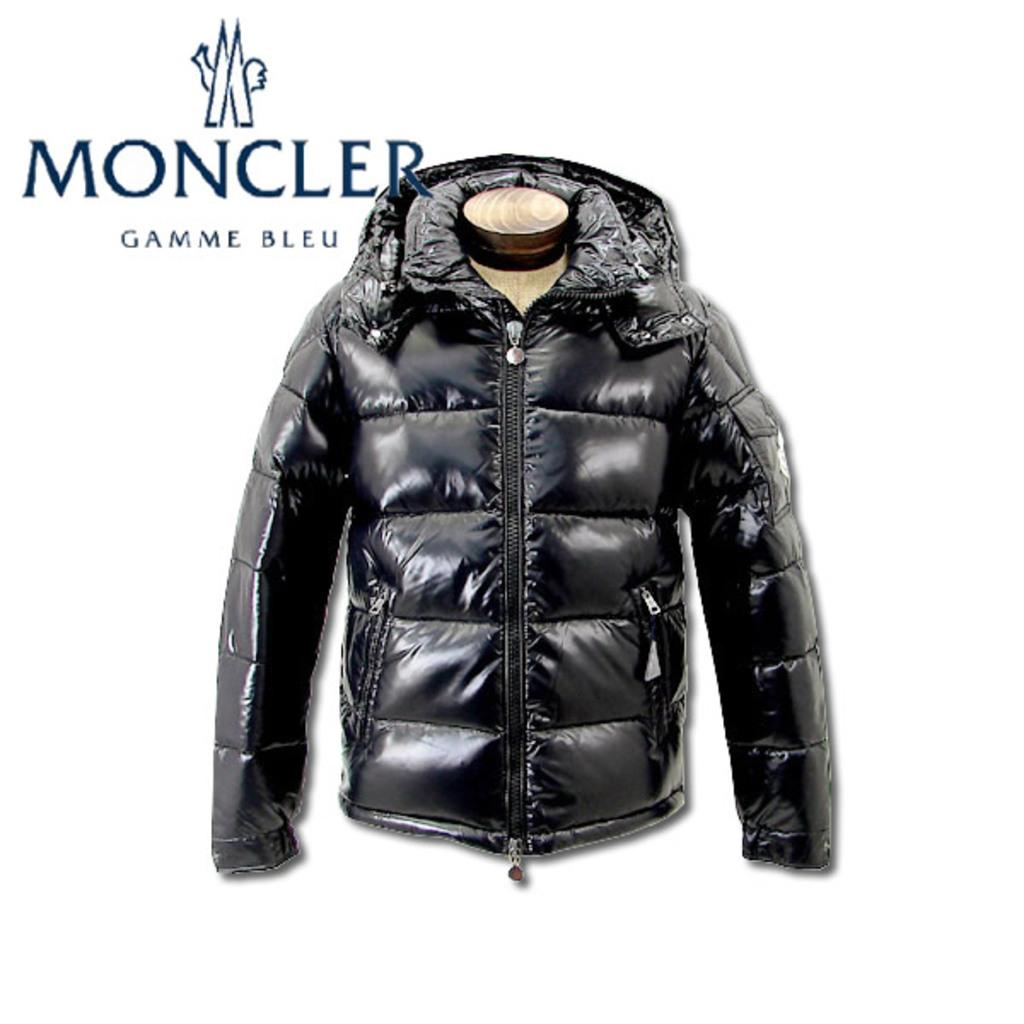What type of clothing is visible in the image? There is a jacket in the image. What color is the jacket? The jacket is black in color. What is the color of the background in the image? The background of the image is white in color. What can be seen in the background besides the color? There is text written in the background of the image. What arithmetic problem is being solved on the heart in the image? There is no heart or arithmetic problem present in the image. What type of game is being played with the jacket in the image? There is no game being played in the image; it simply shows a jacket and a white background with text. 